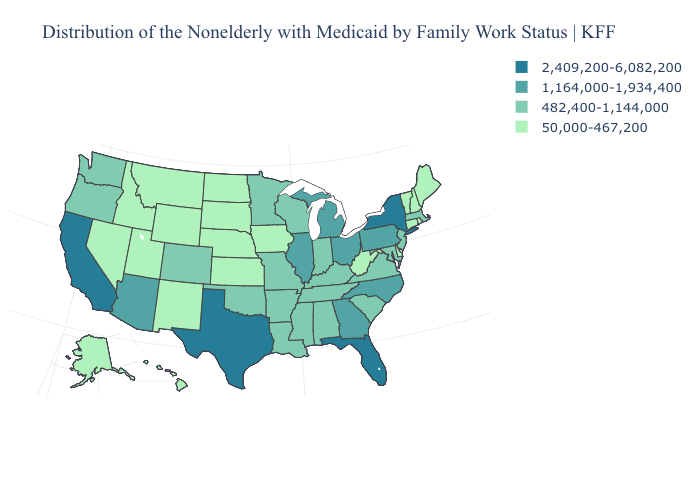Does the map have missing data?
Write a very short answer. No. What is the value of Iowa?
Write a very short answer. 50,000-467,200. Name the states that have a value in the range 1,164,000-1,934,400?
Answer briefly. Arizona, Georgia, Illinois, Michigan, North Carolina, Ohio, Pennsylvania. Among the states that border Utah , which have the highest value?
Short answer required. Arizona. Is the legend a continuous bar?
Write a very short answer. No. Does Nebraska have the highest value in the MidWest?
Concise answer only. No. Name the states that have a value in the range 50,000-467,200?
Give a very brief answer. Alaska, Connecticut, Delaware, Hawaii, Idaho, Iowa, Kansas, Maine, Montana, Nebraska, Nevada, New Hampshire, New Mexico, North Dakota, Rhode Island, South Dakota, Utah, Vermont, West Virginia, Wyoming. What is the lowest value in the MidWest?
Be succinct. 50,000-467,200. Name the states that have a value in the range 1,164,000-1,934,400?
Concise answer only. Arizona, Georgia, Illinois, Michigan, North Carolina, Ohio, Pennsylvania. What is the lowest value in the Northeast?
Be succinct. 50,000-467,200. Which states have the lowest value in the Northeast?
Answer briefly. Connecticut, Maine, New Hampshire, Rhode Island, Vermont. Name the states that have a value in the range 482,400-1,144,000?
Answer briefly. Alabama, Arkansas, Colorado, Indiana, Kentucky, Louisiana, Maryland, Massachusetts, Minnesota, Mississippi, Missouri, New Jersey, Oklahoma, Oregon, South Carolina, Tennessee, Virginia, Washington, Wisconsin. Name the states that have a value in the range 50,000-467,200?
Give a very brief answer. Alaska, Connecticut, Delaware, Hawaii, Idaho, Iowa, Kansas, Maine, Montana, Nebraska, Nevada, New Hampshire, New Mexico, North Dakota, Rhode Island, South Dakota, Utah, Vermont, West Virginia, Wyoming. Name the states that have a value in the range 482,400-1,144,000?
Be succinct. Alabama, Arkansas, Colorado, Indiana, Kentucky, Louisiana, Maryland, Massachusetts, Minnesota, Mississippi, Missouri, New Jersey, Oklahoma, Oregon, South Carolina, Tennessee, Virginia, Washington, Wisconsin. Does Minnesota have the same value as Ohio?
Write a very short answer. No. 